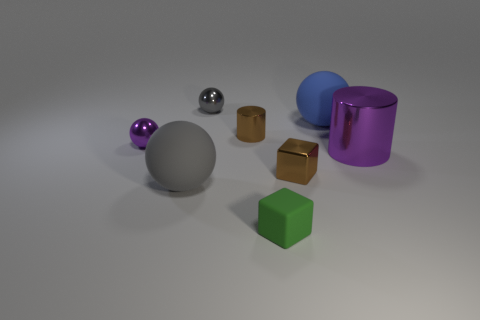Describe the lighting in the scene. The lighting in the scene appears to be soft and diffused, coming from above and casting gentle shadows directly beneath the objects. This indicates an evenly distributed light source, possibly from a studio light setup, which accentuates the shapes and textures of the objects without creating harsh glares. 